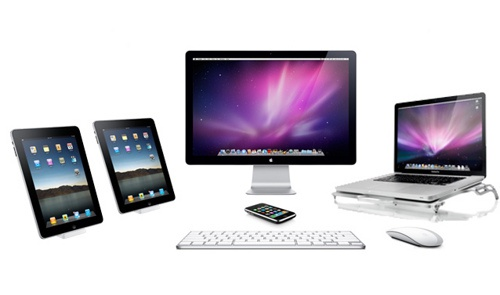Describe the objects in this image and their specific colors. I can see tv in white, black, purple, and navy tones, cell phone in white, black, gray, and blue tones, cell phone in white, black, gray, and blue tones, keyboard in white, darkgray, and lightgray tones, and keyboard in white, black, gray, darkgray, and lightgray tones in this image. 